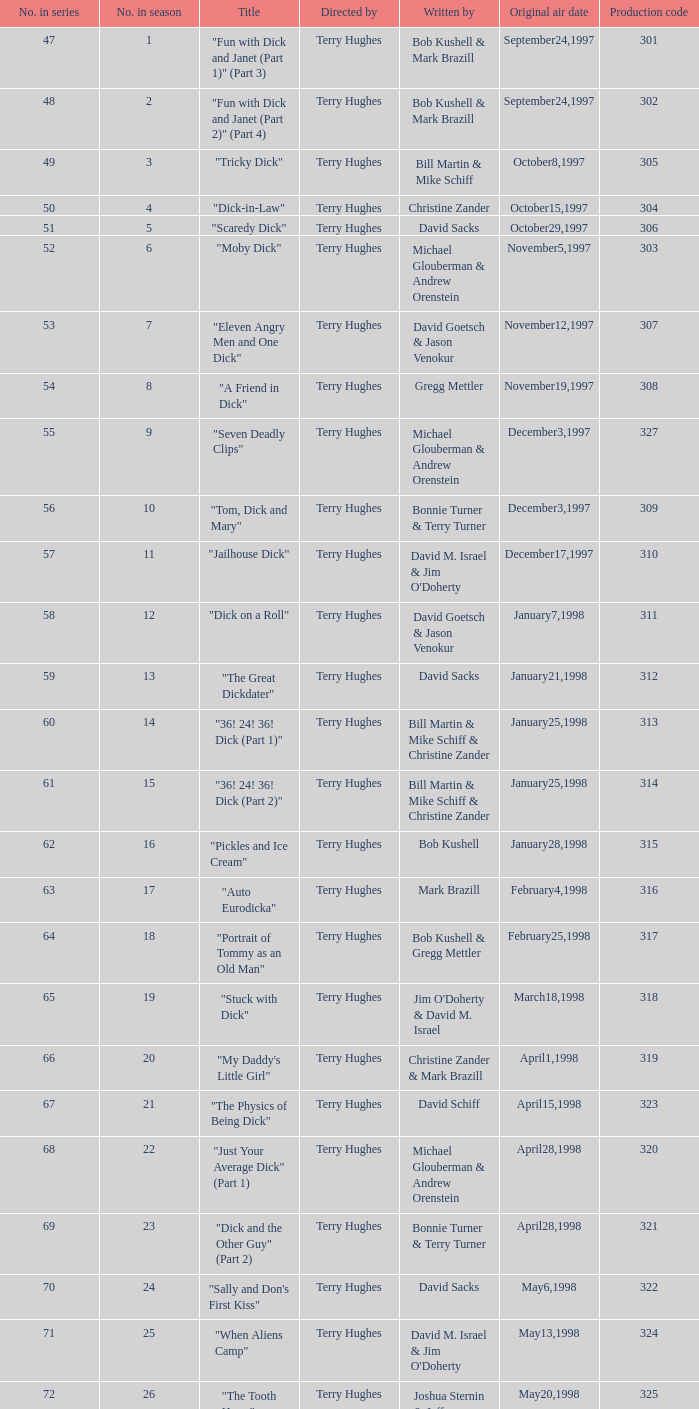What is the heading of episode 10? "Tom, Dick and Mary". 